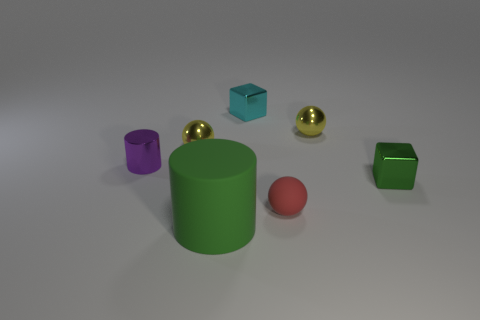What number of other objects are the same color as the shiny cylinder?
Offer a very short reply. 0. There is a cylinder that is behind the small red matte ball; is its size the same as the rubber object left of the small cyan shiny cube?
Your answer should be very brief. No. How big is the green object that is on the left side of the tiny yellow object that is right of the red rubber sphere?
Your answer should be compact. Large. There is a tiny object that is to the right of the tiny red rubber object and behind the tiny green shiny block; what material is it?
Your answer should be very brief. Metal. The large cylinder is what color?
Make the answer very short. Green. There is a green object that is on the right side of the matte cylinder; what shape is it?
Your response must be concise. Cube. Are there any yellow metallic things that are right of the yellow sphere left of the matte thing that is in front of the tiny rubber sphere?
Your response must be concise. Yes. Are any big metal cubes visible?
Your response must be concise. No. Does the large green object that is in front of the tiny matte ball have the same material as the ball in front of the small green cube?
Offer a very short reply. Yes. What size is the cylinder that is right of the small yellow metallic ball on the left side of the object in front of the small matte object?
Your answer should be very brief. Large. 